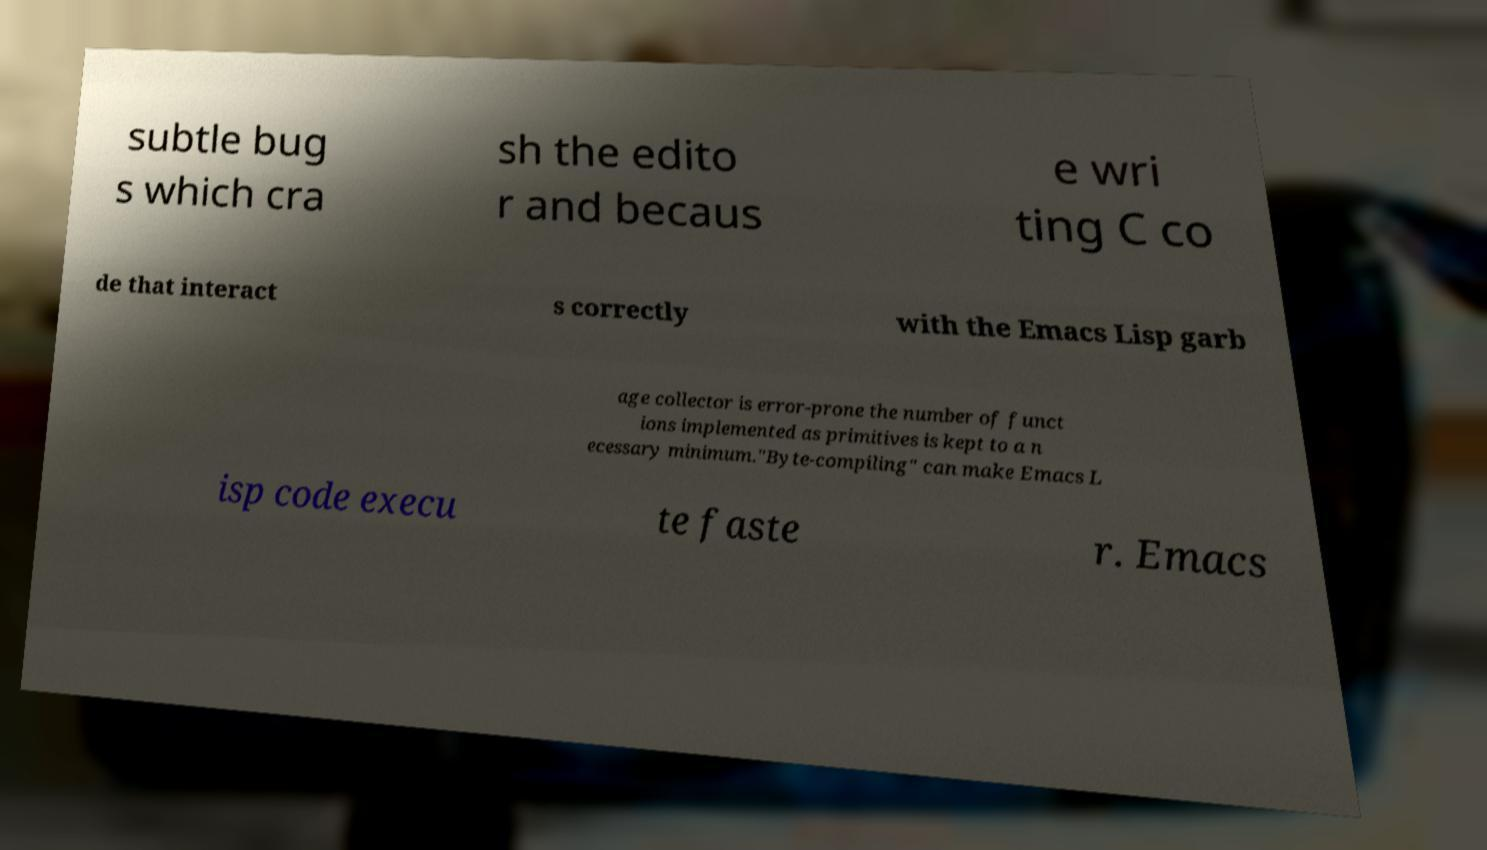Please identify and transcribe the text found in this image. subtle bug s which cra sh the edito r and becaus e wri ting C co de that interact s correctly with the Emacs Lisp garb age collector is error-prone the number of funct ions implemented as primitives is kept to a n ecessary minimum."Byte-compiling" can make Emacs L isp code execu te faste r. Emacs 